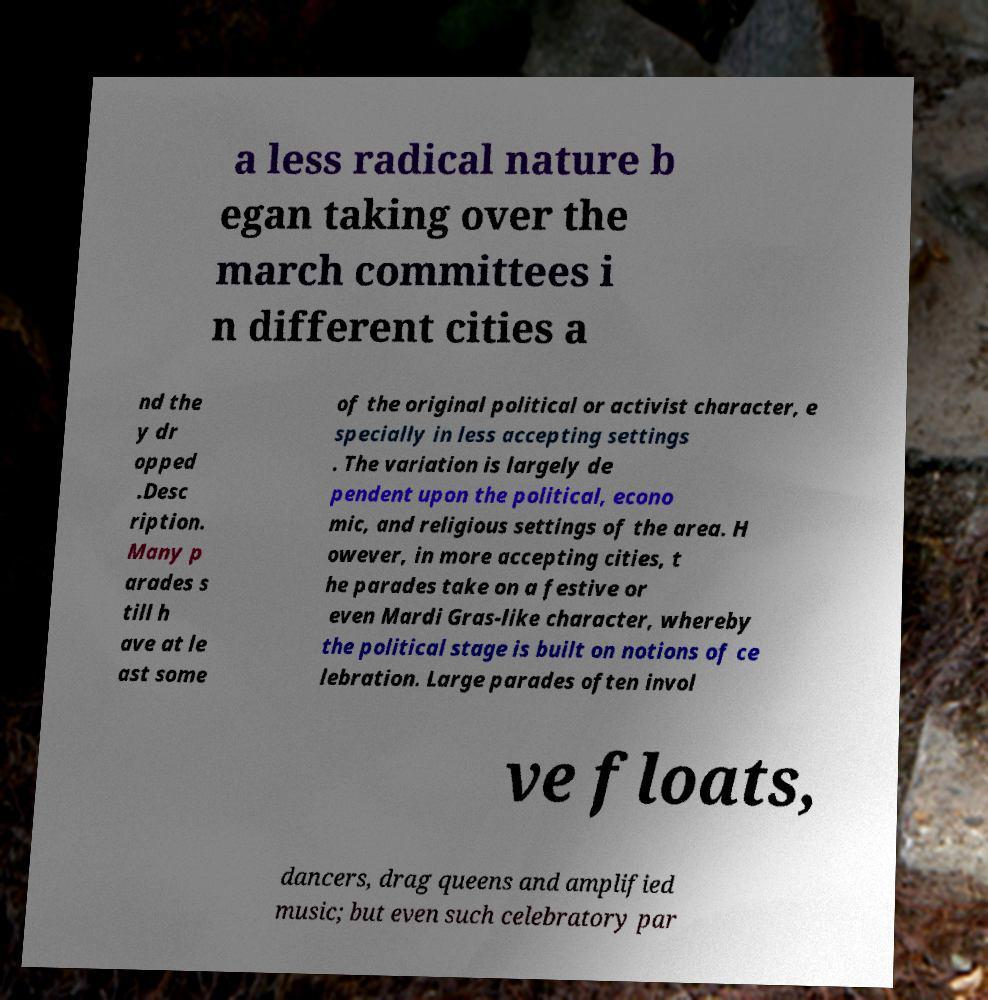There's text embedded in this image that I need extracted. Can you transcribe it verbatim? a less radical nature b egan taking over the march committees i n different cities a nd the y dr opped .Desc ription. Many p arades s till h ave at le ast some of the original political or activist character, e specially in less accepting settings . The variation is largely de pendent upon the political, econo mic, and religious settings of the area. H owever, in more accepting cities, t he parades take on a festive or even Mardi Gras-like character, whereby the political stage is built on notions of ce lebration. Large parades often invol ve floats, dancers, drag queens and amplified music; but even such celebratory par 